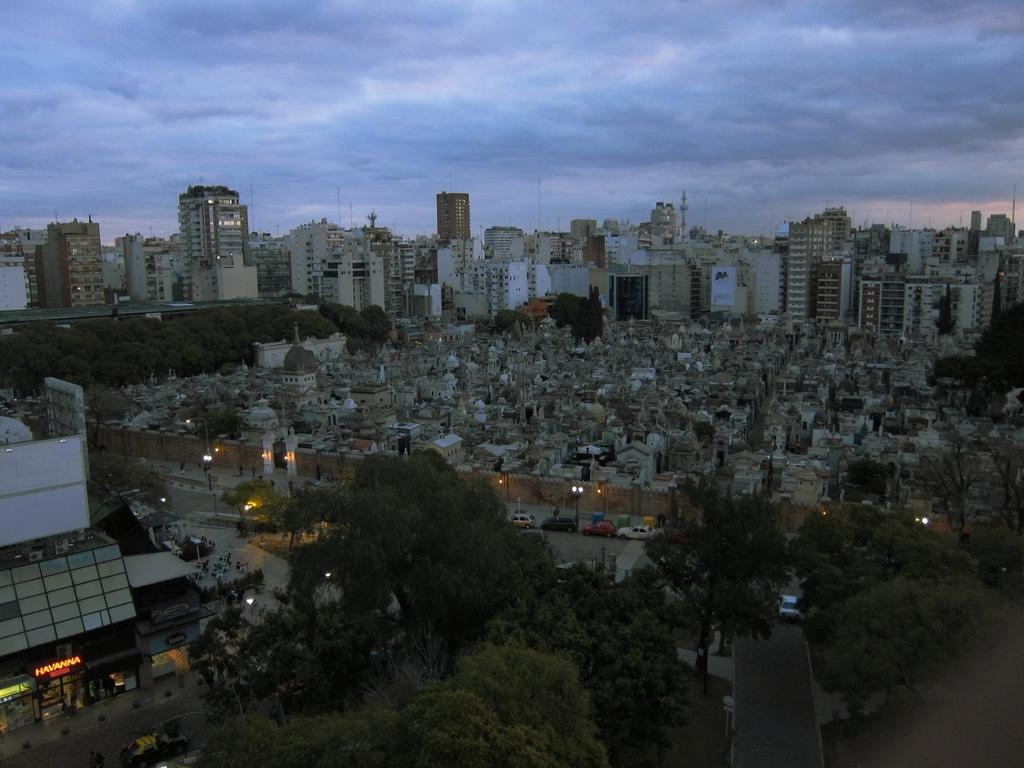What type of vegetation can be seen in the image? There are trees in the image. What is the color of the trees? The trees are green in color. What else can be seen in the image besides the trees? There is a road, vehicles, buildings, lights, and the sky visible in the image. Can you describe the road in the image? There is a road in the image, and it has vehicles on it. What is visible in the background of the image? The sky and buildings are visible in the background of the image. What type of mouth can be seen on the plot in the image? There is no mouth or plot present in the image. What type of street is visible in the image? There is no street visible in the image; it features a road instead. 